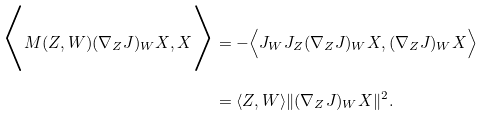<formula> <loc_0><loc_0><loc_500><loc_500>\Big { \langle } M ( Z , W ) ( \nabla _ { Z } J ) _ { W } X , X \Big { \rangle } & = - \Big { \langle } J _ { W } J _ { Z } ( \nabla _ { Z } J ) _ { W } X , ( \nabla _ { Z } J ) _ { W } X \Big { \rangle } \\ & = \langle Z , W \rangle \| ( \nabla _ { Z } J ) _ { W } X \| ^ { 2 } .</formula> 